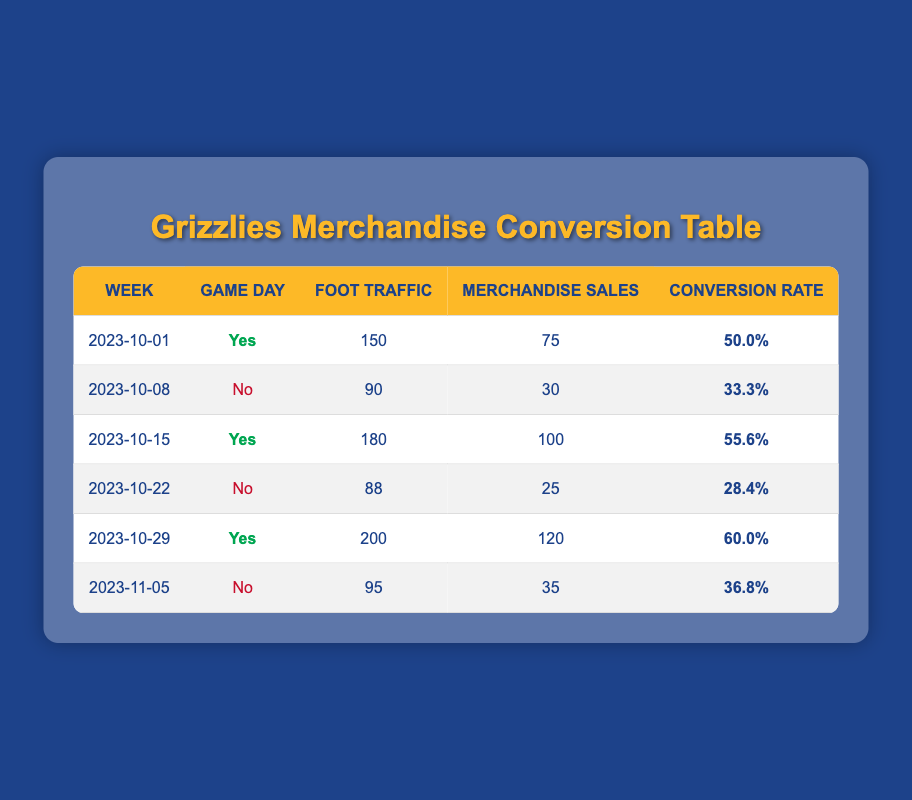What was the foot traffic on the week of October 15, 2023? The foot traffic for the week of October 15 is listed in the table under the 'Foot Traffic' column corresponding to that week, which shows a value of 180.
Answer: 180 What is the conversion rate for the week of October 8, 2023? The conversion rate for the week of October 8 is clearly shown in the 'Conversion Rate' column for that specific week, which is 33.3%.
Answer: 33.3% How many merchandise sales were made on game days? We can find the merchandise sales on game days by looking at the rows where 'Game Day' is marked as 'Yes' (2023-10-01, 2023-10-15, and 2023-10-29). Their sales are 75, 100, and 120 respectively. Adding these gives 75 + 100 + 120 = 295.
Answer: 295 What is the average foot traffic on non-game days? For non-game days (2023-10-08, 2023-10-22, and 2023-11-05), the foot traffic values are 90, 88, and 95, respectively. Summing these gives 90 + 88 + 95 = 273, and dividing by the number of weeks (3) gives an average of 273 / 3 = 91.
Answer: 91 Did the conversion rate increase from October 15 to October 29, 2023? The conversion rate for October 15 is 55.6%, and for October 29, it is 60.0%. Since 60.0% is greater than 55.6%, the conversion rate did increase.
Answer: Yes What is the total foot traffic recorded over all weeks? To find the total foot traffic, we need to sum up the 'Foot Traffic' values for all weeks: 150 + 90 + 180 + 88 + 200 + 95 = 803.
Answer: 803 How many weeks had a conversion rate above 50%? Looking through the 'Conversion Rate' column, we find 50.0% (week of 2023-10-01), 55.6% (week of 2023-10-15), and 60.0% (week of 2023-10-29). This means 3 weeks had a conversion rate above 50%.
Answer: 3 What was the merchandise sales difference between the highest and lowest weeks? The highest merchandise sales recorded was 120 (week of October 29), and the lowest was 25 (week of October 22). The difference is 120 - 25 = 95.
Answer: 95 